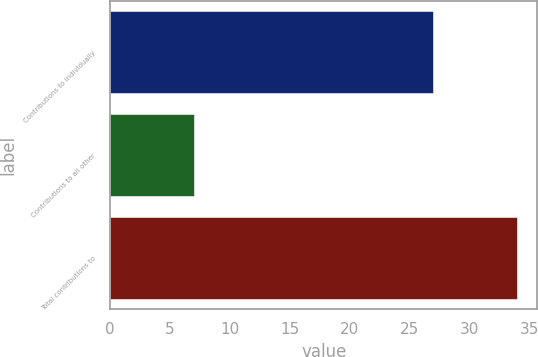<chart> <loc_0><loc_0><loc_500><loc_500><bar_chart><fcel>Contributions to individually<fcel>Contributions to all other<fcel>Total contributions to<nl><fcel>27<fcel>7<fcel>34<nl></chart> 